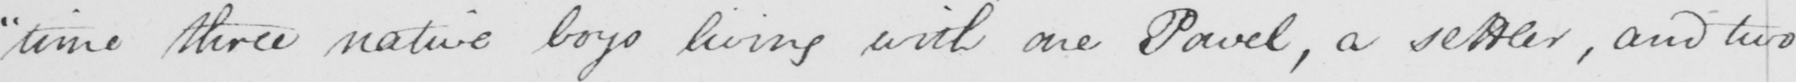Please transcribe the handwritten text in this image. " time three native boys living with one Pavel , a settler , and two 